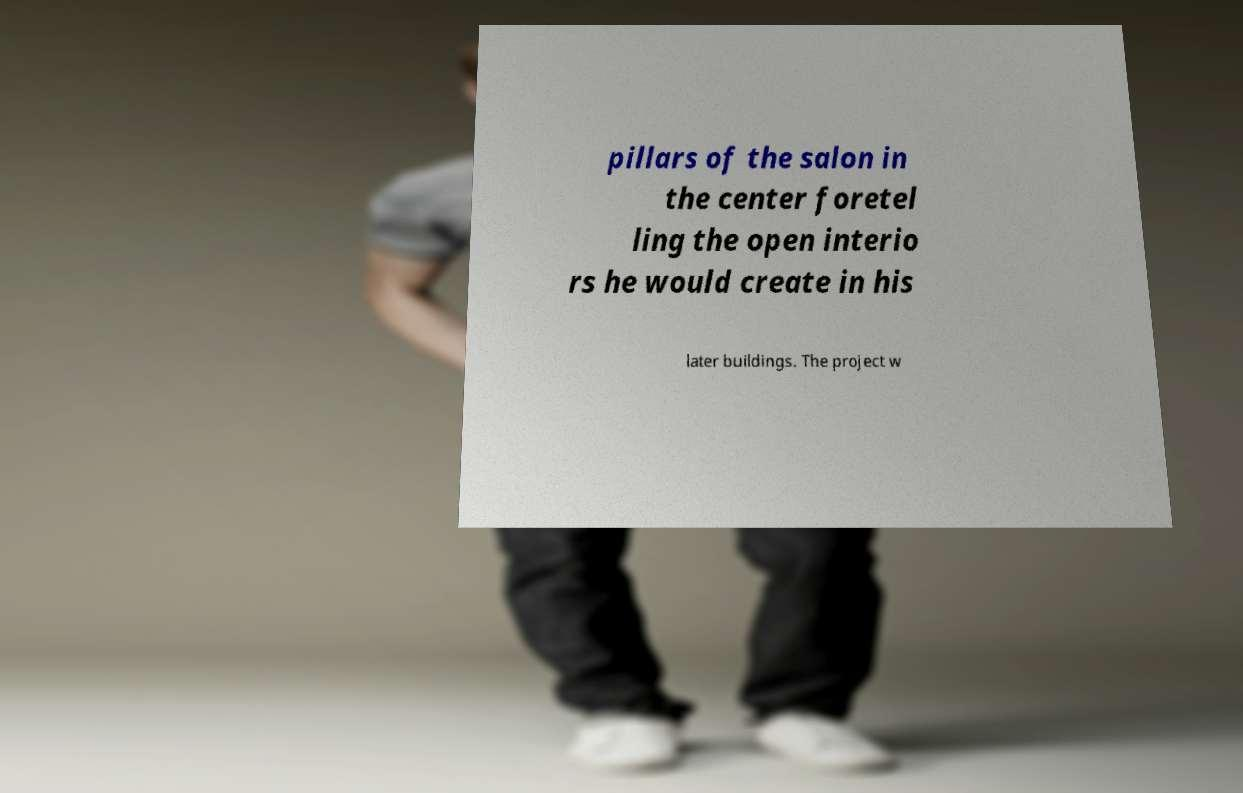Can you read and provide the text displayed in the image?This photo seems to have some interesting text. Can you extract and type it out for me? pillars of the salon in the center foretel ling the open interio rs he would create in his later buildings. The project w 